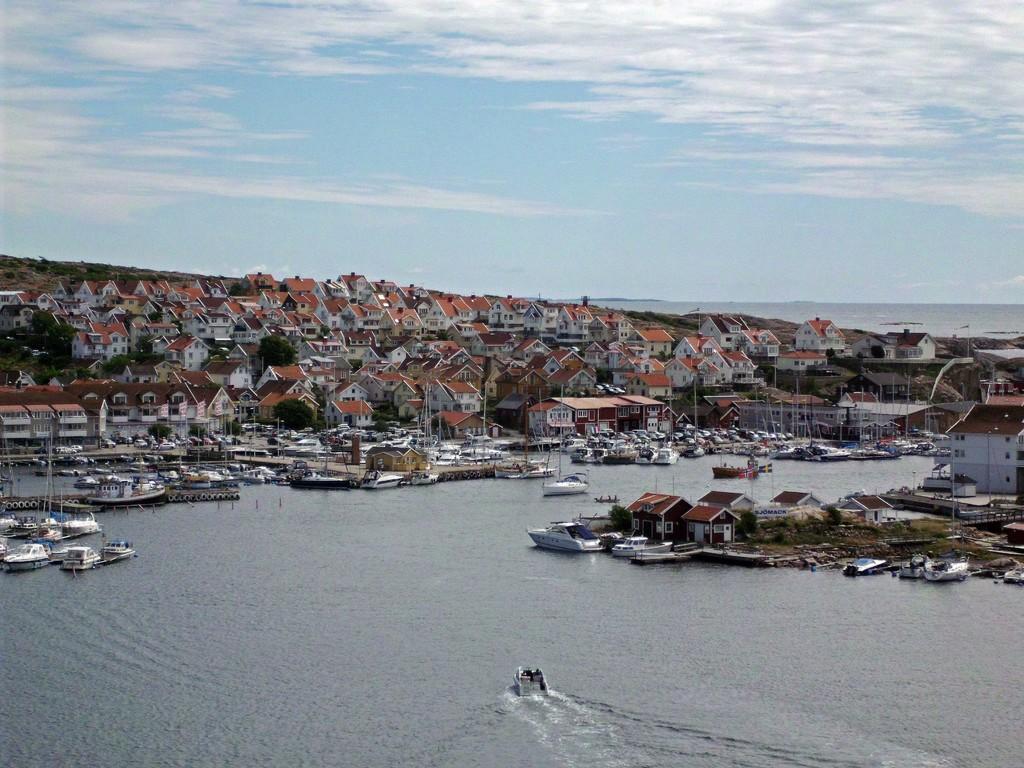Please provide a concise description of this image. In this image there are few boats and ships on the river. In the background there are buildings and the sky. 